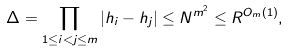Convert formula to latex. <formula><loc_0><loc_0><loc_500><loc_500>\Delta = \prod _ { 1 \leq i < j \leq m } | h _ { i } - h _ { j } | \leq N ^ { m ^ { 2 } } \leq R ^ { O _ { m } ( 1 ) } ,</formula> 